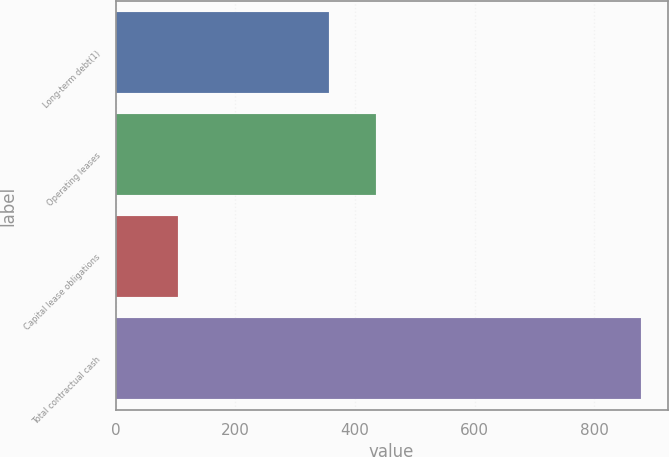Convert chart to OTSL. <chart><loc_0><loc_0><loc_500><loc_500><bar_chart><fcel>Long-term debt(1)<fcel>Operating leases<fcel>Capital lease obligations<fcel>Total contractual cash<nl><fcel>357<fcel>434.5<fcel>104<fcel>879<nl></chart> 